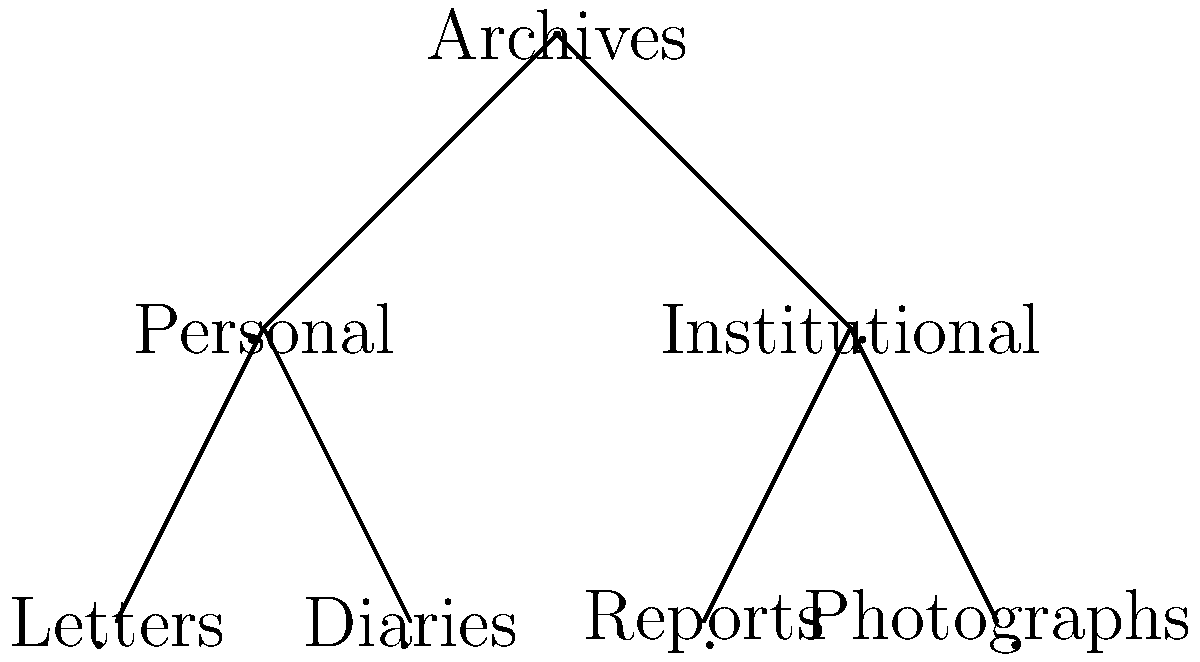In the hierarchical tree structure representing archival collections, how many leaf nodes are present, and what do they represent in the context of archival materials? To answer this question, let's analyze the hierarchical tree structure step by step:

1. Identify the root node:
   The root node is "Archives" at the top of the tree.

2. Identify the second level of nodes:
   There are two nodes at the second level: "Personal" and "Institutional".

3. Identify the leaf nodes:
   Leaf nodes are nodes that have no children. In this tree, we can see four leaf nodes:
   a. "Letters"
   b. "Diaries"
   c. "Reports"
   d. "Photographs"

4. Count the number of leaf nodes:
   There are 4 leaf nodes in total.

5. Interpret the leaf nodes in the context of archival materials:
   - "Letters" and "Diaries" are under the "Personal" category, representing personal archival materials.
   - "Reports" and "Photographs" are under the "Institutional" category, representing institutional archival materials.

These leaf nodes represent specific types of archival documents or items that are the most granular level of classification in this hierarchical structure.
Answer: 4 leaf nodes: Letters, Diaries, Reports, and Photographs 